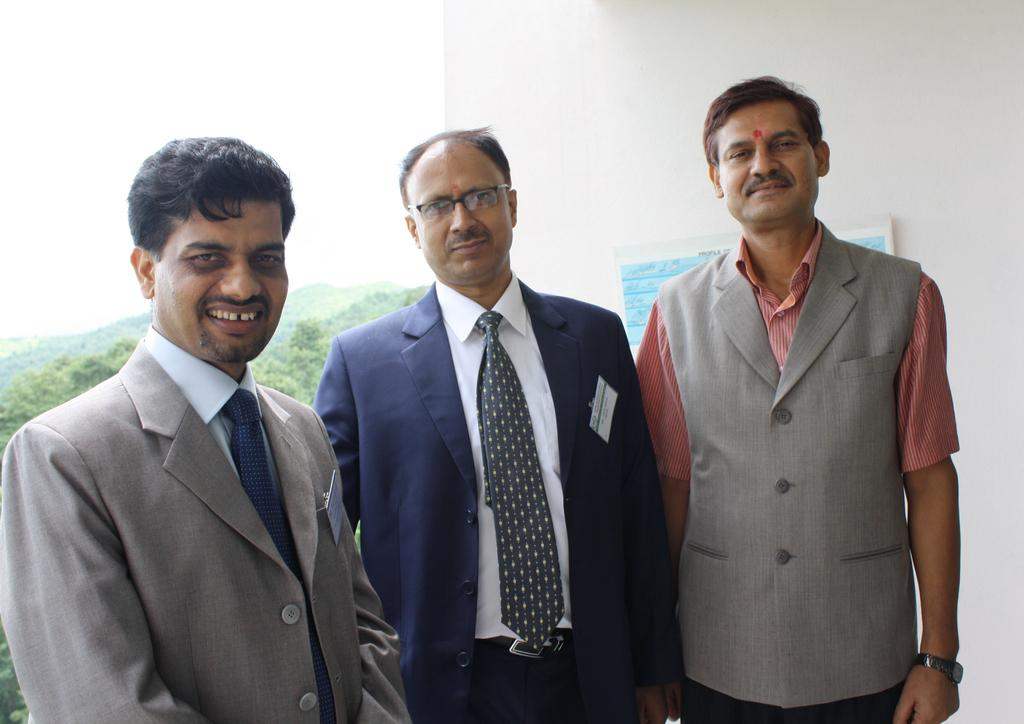How many people are in the image? There are three men in the image. What are the men doing in the image? The men are standing, seeing, and smiling. What can be seen in the background of the image? There is a wall, a poster on the wall, trees, and the sky visible in the background of the image. What is the thought process of the trees in the image? Trees do not have thought processes, as they are inanimate objects. 